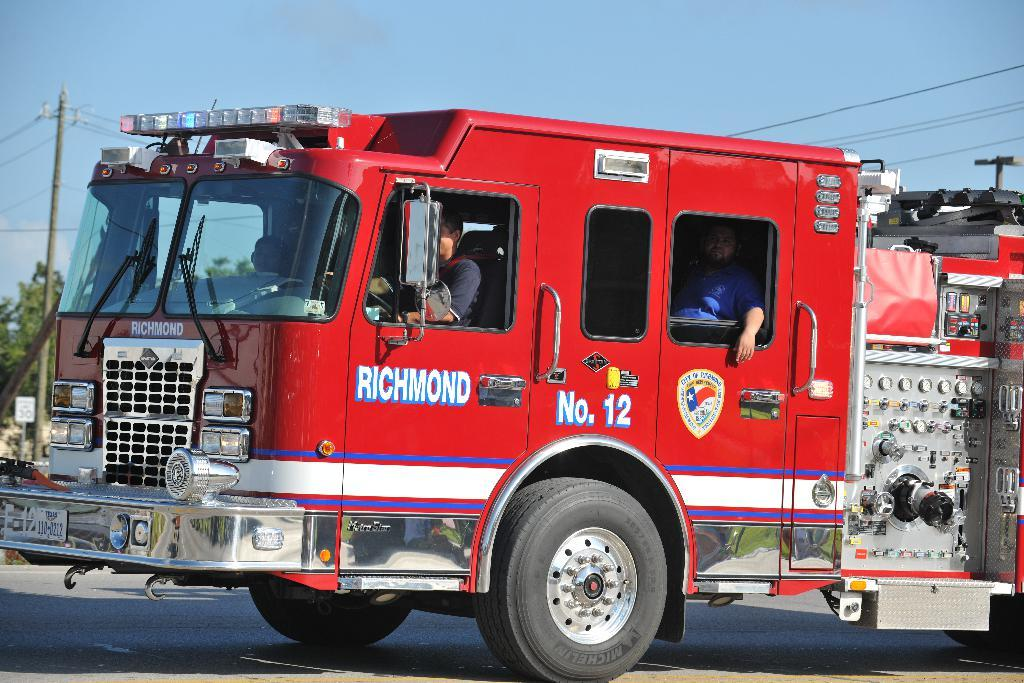What is on the road in the image? There is a vehicle on the road in the image. How many people are inside the vehicle? There are three persons inside the vehicle. What can be seen besides the vehicle in the image? There is a pole and trees in the image. What is visible in the background of the image? The sky is visible in the background of the image. What type of music can be heard coming from the vehicle in the image? There is no indication of any music or sound in the image, so it cannot be determined what type of music might be heard. 